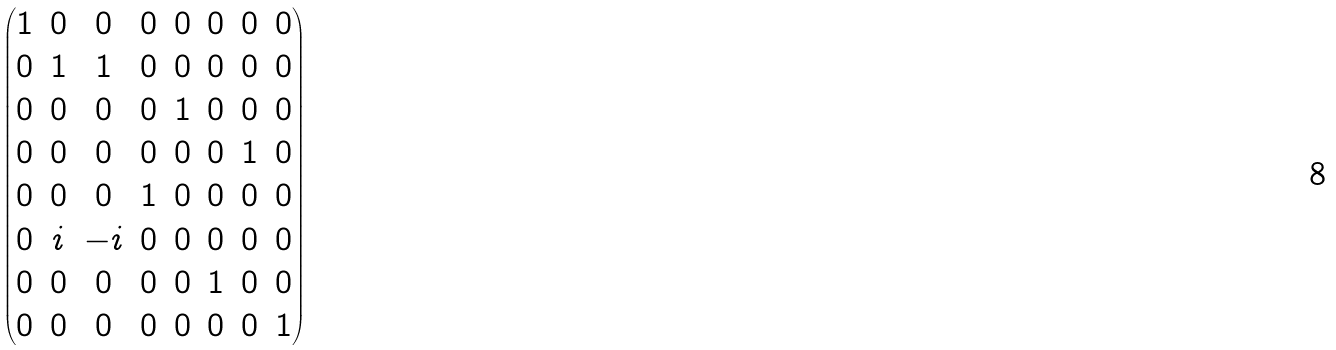<formula> <loc_0><loc_0><loc_500><loc_500>\begin{pmatrix} 1 & 0 & 0 & 0 & 0 & 0 & 0 & 0 \\ 0 & 1 & 1 & 0 & 0 & 0 & 0 & 0 \\ 0 & 0 & 0 & 0 & 1 & 0 & 0 & 0 \\ 0 & 0 & 0 & 0 & 0 & 0 & 1 & 0 \\ 0 & 0 & 0 & 1 & 0 & 0 & 0 & 0 \\ 0 & i & - i & 0 & 0 & 0 & 0 & 0 \\ 0 & 0 & 0 & 0 & 0 & 1 & 0 & 0 \\ 0 & 0 & 0 & 0 & 0 & 0 & 0 & 1 \end{pmatrix}</formula> 